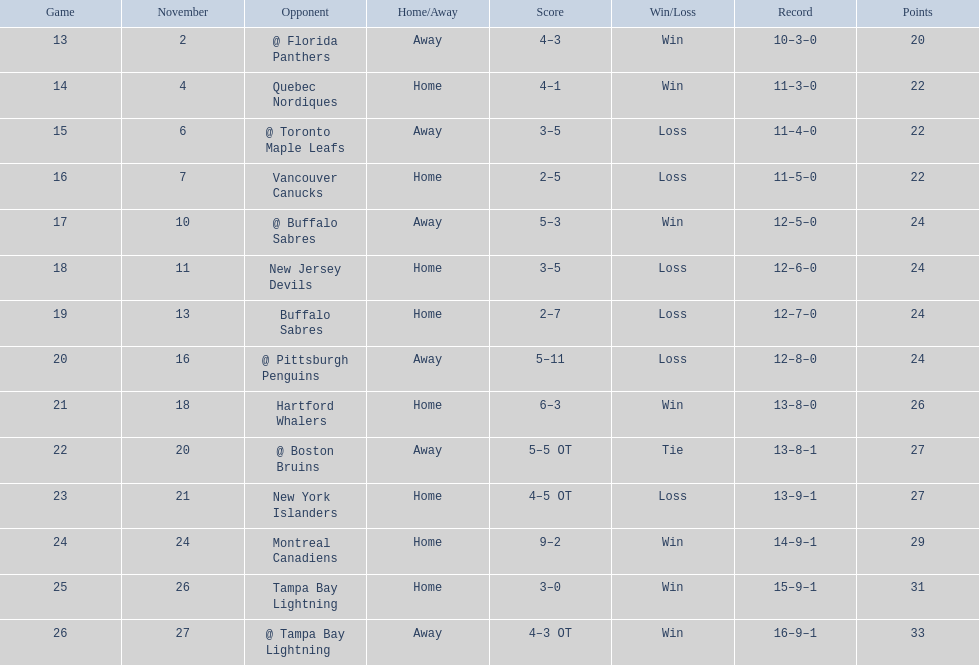Were the new jersey devils in last place according to the chart? No. 